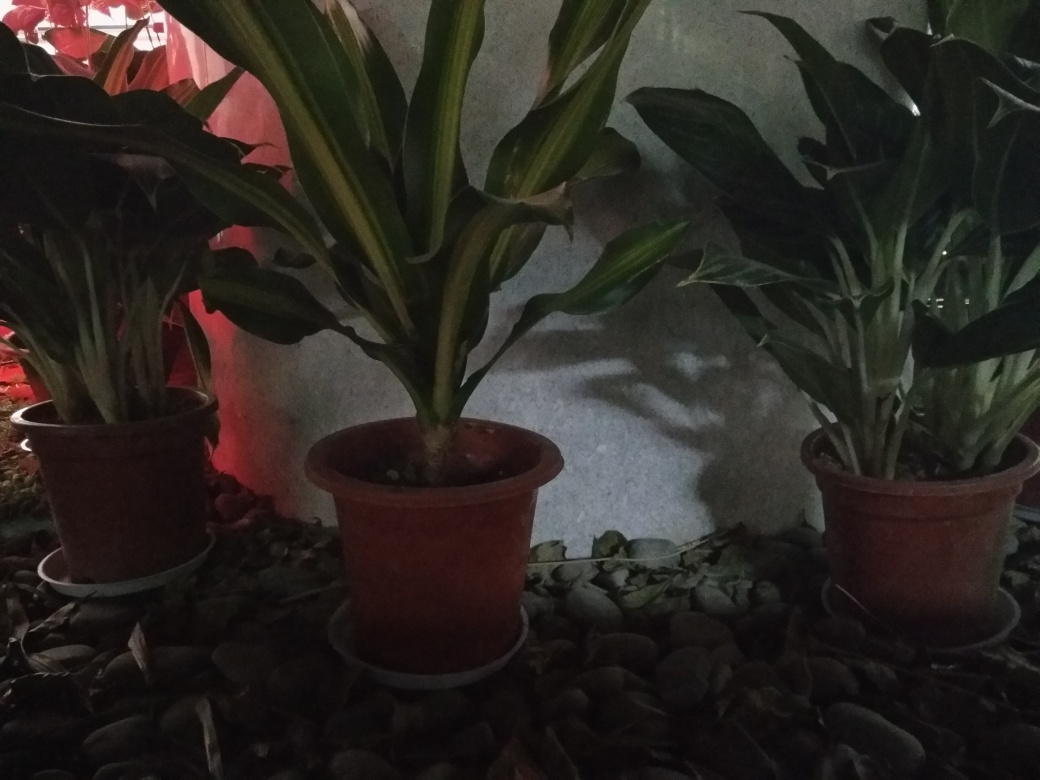Considering the composition of this image, what could improve its aesthetic? Improving the lighting could significantly enhance the image's aesthetic, making it feel more vibrant and alive. Experimenting with the angles could add a dynamic perspective, and incorporating additional colorful elements, such as flowering plants or decorative items, might also make the composition more visually appealing. 